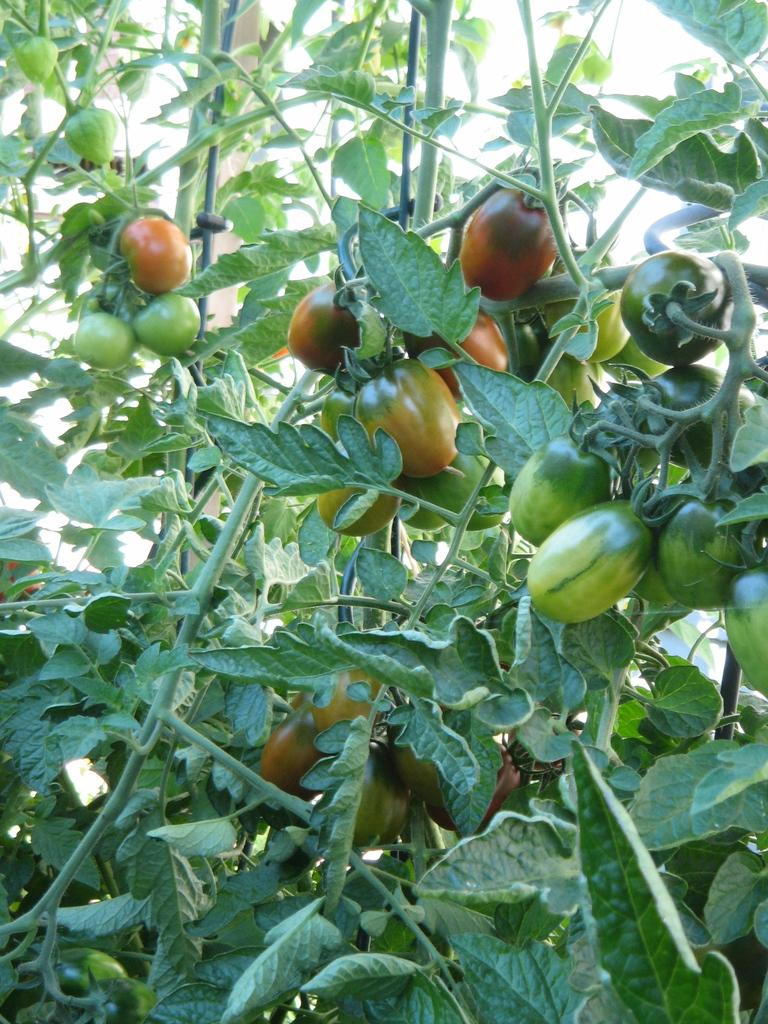What is the main subject of the picture? The main subject of the picture is a tree. What is unique about this tree? The tree has vegetables on it. What type of star can be seen shining brightly in the picture? There is no star visible in the picture; it features a tree with vegetables on it. How many ladybugs are crawling on the tree in the picture? There are no ladybugs present in the picture; it only shows a tree with vegetables on it. 